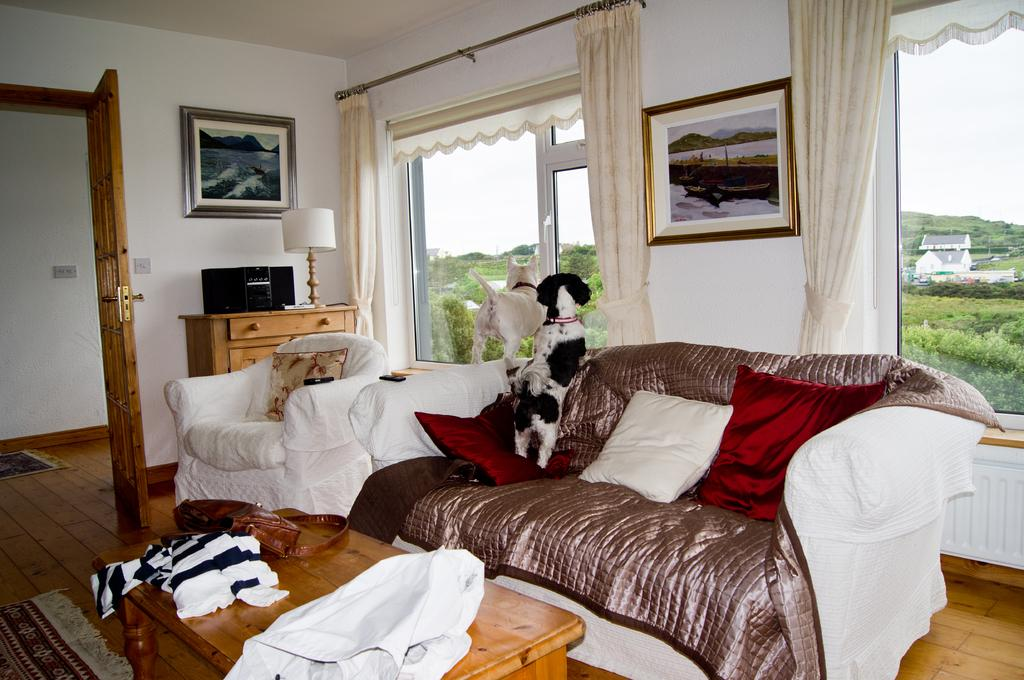What type of furniture is present in the image? There is a sofa and a chair in the image. What is the position of the animals in the image? There are two animals on the sofa or chair in the image. What can be seen on the wall in the image? There are frames on the wall in the image. What type of natural scenery is visible in the image? There are trees visible in the image. What type of man-made structures can be seen in the image? There are buildings visible in the image. What type of curve can be seen in the image? There is no curve present in the image. What type of destruction is depicted in the image? There is no destruction depicted in the image. 